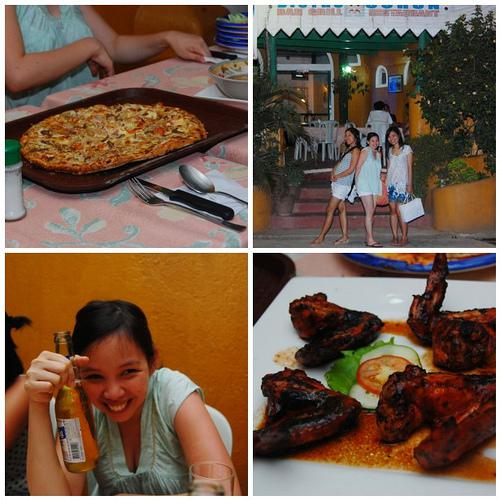Question: where are the women in the upper right picture?
Choices:
A. Next to a car.
B. In a park.
C. In front of a restaurant.
D. By a lake.
Answer with the letter. Answer: C Question: how many separate picture are there?
Choices:
A. Two.
B. Four.
C. Three.
D. Five.
Answer with the letter. Answer: B Question: when was the upper right hand picture taken?
Choices:
A. Daytime.
B. Dusk.
C. Early morning.
D. Evening.
Answer with the letter. Answer: D Question: what is the food in the bottom right picture?
Choices:
A. Chicken.
B. Beans.
C. Lettuce.
D. Peanut butter.
Answer with the letter. Answer: A Question: what picture has the most people?
Choices:
A. The bottom picture.
B. The left-hand picture.
C. The top right picture.
D. The first picture.
Answer with the letter. Answer: C 